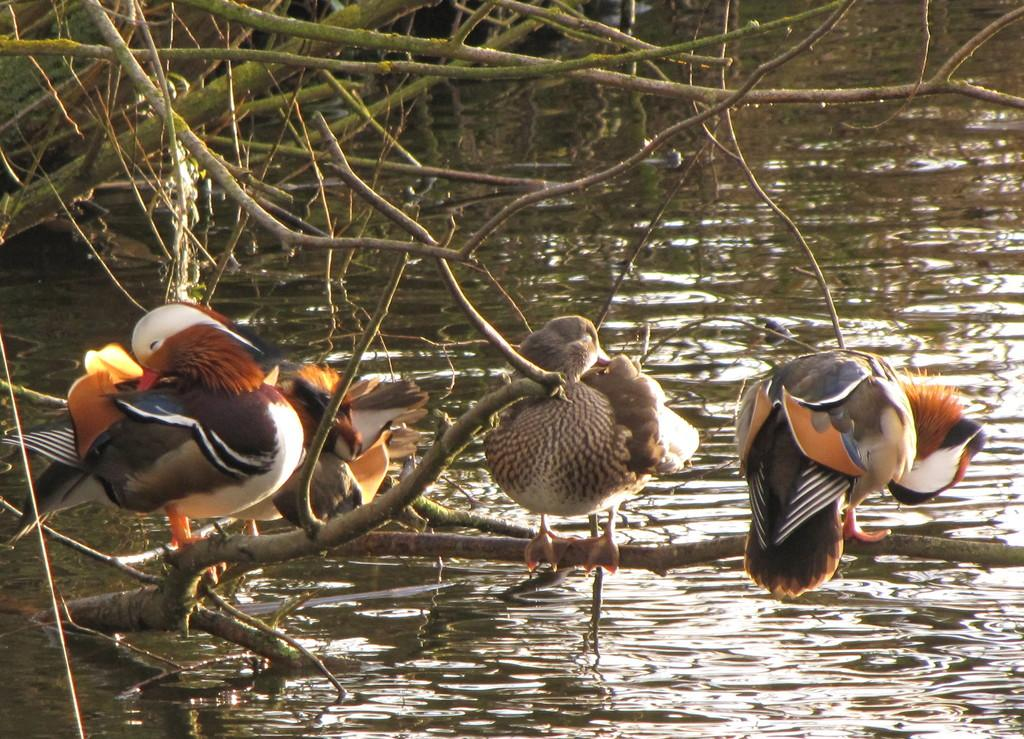Where was the picture taken? The picture was clicked outside the city. How many birds can be seen in the image? There are three birds in the image. What are the birds doing in the image? The birds are standing on the branch of a tree. What can be seen in the background of the image? There is a water body visible in the background, along with tree stems. What type of mine can be seen in the image? There is no mine present in the image; it features three birds standing on a tree branch outside the city. How hot is the frame of the image? The concept of a "hot frame" is not applicable to this image, as it refers to the temperature of the physical frame, which is not visible in the image. 